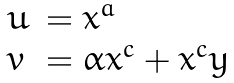Convert formula to latex. <formula><loc_0><loc_0><loc_500><loc_500>\begin{array} { l l } u & = x ^ { a } \\ v & = \alpha x ^ { c } + x ^ { c } y \end{array}</formula> 